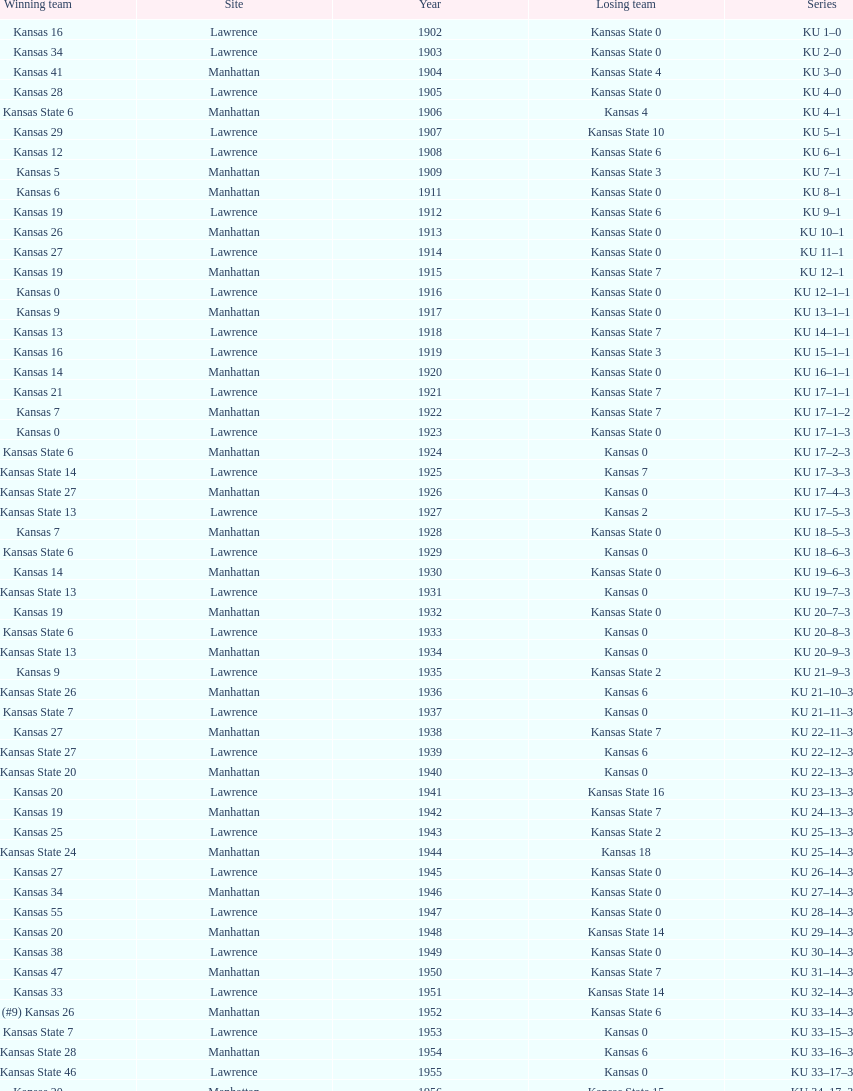What was the number of wins kansas state had in manhattan? 8. 